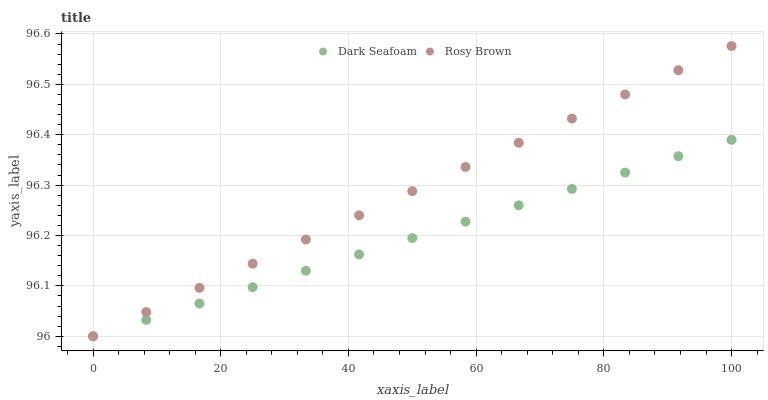Does Dark Seafoam have the minimum area under the curve?
Answer yes or no. Yes. Does Rosy Brown have the maximum area under the curve?
Answer yes or no. Yes. Does Rosy Brown have the minimum area under the curve?
Answer yes or no. No. Is Dark Seafoam the smoothest?
Answer yes or no. Yes. Is Rosy Brown the roughest?
Answer yes or no. Yes. Is Rosy Brown the smoothest?
Answer yes or no. No. Does Dark Seafoam have the lowest value?
Answer yes or no. Yes. Does Rosy Brown have the highest value?
Answer yes or no. Yes. Does Dark Seafoam intersect Rosy Brown?
Answer yes or no. Yes. Is Dark Seafoam less than Rosy Brown?
Answer yes or no. No. Is Dark Seafoam greater than Rosy Brown?
Answer yes or no. No. 